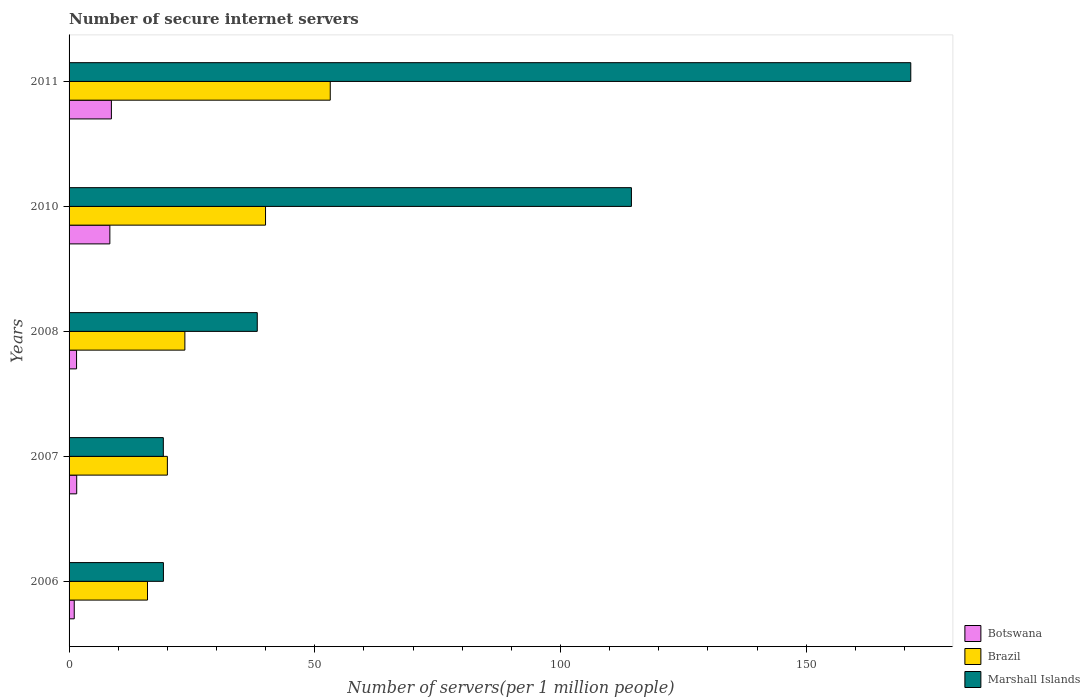How many different coloured bars are there?
Your response must be concise. 3. Are the number of bars on each tick of the Y-axis equal?
Offer a terse response. Yes. How many bars are there on the 2nd tick from the top?
Provide a succinct answer. 3. What is the label of the 1st group of bars from the top?
Your answer should be very brief. 2011. What is the number of secure internet servers in Brazil in 2007?
Make the answer very short. 20.01. Across all years, what is the maximum number of secure internet servers in Botswana?
Ensure brevity in your answer.  8.61. Across all years, what is the minimum number of secure internet servers in Botswana?
Offer a terse response. 1.06. In which year was the number of secure internet servers in Botswana minimum?
Your response must be concise. 2006. What is the total number of secure internet servers in Brazil in the graph?
Provide a succinct answer. 152.67. What is the difference between the number of secure internet servers in Brazil in 2008 and that in 2011?
Your response must be concise. -29.59. What is the difference between the number of secure internet servers in Botswana in 2011 and the number of secure internet servers in Brazil in 2008?
Your answer should be very brief. -14.95. What is the average number of secure internet servers in Marshall Islands per year?
Make the answer very short. 72.48. In the year 2010, what is the difference between the number of secure internet servers in Brazil and number of secure internet servers in Marshall Islands?
Offer a terse response. -74.46. In how many years, is the number of secure internet servers in Botswana greater than 80 ?
Your response must be concise. 0. What is the ratio of the number of secure internet servers in Marshall Islands in 2008 to that in 2010?
Ensure brevity in your answer.  0.33. Is the number of secure internet servers in Marshall Islands in 2010 less than that in 2011?
Offer a terse response. Yes. Is the difference between the number of secure internet servers in Brazil in 2010 and 2011 greater than the difference between the number of secure internet servers in Marshall Islands in 2010 and 2011?
Your answer should be compact. Yes. What is the difference between the highest and the second highest number of secure internet servers in Marshall Islands?
Provide a short and direct response. 56.85. What is the difference between the highest and the lowest number of secure internet servers in Brazil?
Your answer should be compact. 37.19. Is the sum of the number of secure internet servers in Marshall Islands in 2007 and 2011 greater than the maximum number of secure internet servers in Brazil across all years?
Give a very brief answer. Yes. What does the 1st bar from the top in 2011 represents?
Your response must be concise. Marshall Islands. What does the 2nd bar from the bottom in 2010 represents?
Make the answer very short. Brazil. How many years are there in the graph?
Give a very brief answer. 5. What is the difference between two consecutive major ticks on the X-axis?
Provide a short and direct response. 50. Are the values on the major ticks of X-axis written in scientific E-notation?
Ensure brevity in your answer.  No. Does the graph contain any zero values?
Ensure brevity in your answer.  No. Does the graph contain grids?
Ensure brevity in your answer.  No. How many legend labels are there?
Give a very brief answer. 3. How are the legend labels stacked?
Provide a succinct answer. Vertical. What is the title of the graph?
Your response must be concise. Number of secure internet servers. What is the label or title of the X-axis?
Make the answer very short. Number of servers(per 1 million people). What is the Number of servers(per 1 million people) of Botswana in 2006?
Keep it short and to the point. 1.06. What is the Number of servers(per 1 million people) in Brazil in 2006?
Provide a succinct answer. 15.96. What is the Number of servers(per 1 million people) of Marshall Islands in 2006?
Offer a very short reply. 19.2. What is the Number of servers(per 1 million people) of Botswana in 2007?
Keep it short and to the point. 1.55. What is the Number of servers(per 1 million people) in Brazil in 2007?
Your answer should be very brief. 20.01. What is the Number of servers(per 1 million people) of Marshall Islands in 2007?
Keep it short and to the point. 19.18. What is the Number of servers(per 1 million people) of Botswana in 2008?
Your answer should be very brief. 1.52. What is the Number of servers(per 1 million people) in Brazil in 2008?
Provide a short and direct response. 23.57. What is the Number of servers(per 1 million people) in Marshall Islands in 2008?
Make the answer very short. 38.3. What is the Number of servers(per 1 million people) of Botswana in 2010?
Keep it short and to the point. 8.3. What is the Number of servers(per 1 million people) of Brazil in 2010?
Your response must be concise. 39.98. What is the Number of servers(per 1 million people) of Marshall Islands in 2010?
Your answer should be compact. 114.44. What is the Number of servers(per 1 million people) of Botswana in 2011?
Your answer should be compact. 8.61. What is the Number of servers(per 1 million people) in Brazil in 2011?
Your response must be concise. 53.15. What is the Number of servers(per 1 million people) in Marshall Islands in 2011?
Give a very brief answer. 171.29. Across all years, what is the maximum Number of servers(per 1 million people) of Botswana?
Give a very brief answer. 8.61. Across all years, what is the maximum Number of servers(per 1 million people) in Brazil?
Your answer should be compact. 53.15. Across all years, what is the maximum Number of servers(per 1 million people) of Marshall Islands?
Your response must be concise. 171.29. Across all years, what is the minimum Number of servers(per 1 million people) of Botswana?
Give a very brief answer. 1.06. Across all years, what is the minimum Number of servers(per 1 million people) in Brazil?
Give a very brief answer. 15.96. Across all years, what is the minimum Number of servers(per 1 million people) in Marshall Islands?
Offer a terse response. 19.18. What is the total Number of servers(per 1 million people) in Botswana in the graph?
Provide a succinct answer. 21.05. What is the total Number of servers(per 1 million people) in Brazil in the graph?
Your answer should be compact. 152.67. What is the total Number of servers(per 1 million people) of Marshall Islands in the graph?
Provide a short and direct response. 362.42. What is the difference between the Number of servers(per 1 million people) of Botswana in 2006 and that in 2007?
Your response must be concise. -0.5. What is the difference between the Number of servers(per 1 million people) of Brazil in 2006 and that in 2007?
Provide a succinct answer. -4.04. What is the difference between the Number of servers(per 1 million people) of Marshall Islands in 2006 and that in 2007?
Your answer should be very brief. 0.02. What is the difference between the Number of servers(per 1 million people) in Botswana in 2006 and that in 2008?
Make the answer very short. -0.47. What is the difference between the Number of servers(per 1 million people) of Brazil in 2006 and that in 2008?
Your answer should be compact. -7.6. What is the difference between the Number of servers(per 1 million people) in Marshall Islands in 2006 and that in 2008?
Offer a very short reply. -19.1. What is the difference between the Number of servers(per 1 million people) in Botswana in 2006 and that in 2010?
Your answer should be very brief. -7.25. What is the difference between the Number of servers(per 1 million people) of Brazil in 2006 and that in 2010?
Your answer should be very brief. -24.02. What is the difference between the Number of servers(per 1 million people) of Marshall Islands in 2006 and that in 2010?
Offer a very short reply. -95.24. What is the difference between the Number of servers(per 1 million people) in Botswana in 2006 and that in 2011?
Make the answer very short. -7.56. What is the difference between the Number of servers(per 1 million people) in Brazil in 2006 and that in 2011?
Keep it short and to the point. -37.19. What is the difference between the Number of servers(per 1 million people) of Marshall Islands in 2006 and that in 2011?
Offer a terse response. -152.09. What is the difference between the Number of servers(per 1 million people) in Botswana in 2007 and that in 2008?
Offer a very short reply. 0.03. What is the difference between the Number of servers(per 1 million people) of Brazil in 2007 and that in 2008?
Give a very brief answer. -3.56. What is the difference between the Number of servers(per 1 million people) of Marshall Islands in 2007 and that in 2008?
Offer a very short reply. -19.12. What is the difference between the Number of servers(per 1 million people) of Botswana in 2007 and that in 2010?
Offer a very short reply. -6.75. What is the difference between the Number of servers(per 1 million people) of Brazil in 2007 and that in 2010?
Keep it short and to the point. -19.98. What is the difference between the Number of servers(per 1 million people) in Marshall Islands in 2007 and that in 2010?
Make the answer very short. -95.26. What is the difference between the Number of servers(per 1 million people) of Botswana in 2007 and that in 2011?
Your answer should be compact. -7.06. What is the difference between the Number of servers(per 1 million people) in Brazil in 2007 and that in 2011?
Your answer should be very brief. -33.15. What is the difference between the Number of servers(per 1 million people) of Marshall Islands in 2007 and that in 2011?
Provide a succinct answer. -152.11. What is the difference between the Number of servers(per 1 million people) of Botswana in 2008 and that in 2010?
Your response must be concise. -6.78. What is the difference between the Number of servers(per 1 million people) in Brazil in 2008 and that in 2010?
Keep it short and to the point. -16.42. What is the difference between the Number of servers(per 1 million people) of Marshall Islands in 2008 and that in 2010?
Keep it short and to the point. -76.14. What is the difference between the Number of servers(per 1 million people) in Botswana in 2008 and that in 2011?
Offer a terse response. -7.09. What is the difference between the Number of servers(per 1 million people) in Brazil in 2008 and that in 2011?
Offer a terse response. -29.59. What is the difference between the Number of servers(per 1 million people) of Marshall Islands in 2008 and that in 2011?
Offer a very short reply. -133. What is the difference between the Number of servers(per 1 million people) of Botswana in 2010 and that in 2011?
Give a very brief answer. -0.31. What is the difference between the Number of servers(per 1 million people) in Brazil in 2010 and that in 2011?
Make the answer very short. -13.17. What is the difference between the Number of servers(per 1 million people) in Marshall Islands in 2010 and that in 2011?
Your response must be concise. -56.85. What is the difference between the Number of servers(per 1 million people) of Botswana in 2006 and the Number of servers(per 1 million people) of Brazil in 2007?
Offer a terse response. -18.95. What is the difference between the Number of servers(per 1 million people) of Botswana in 2006 and the Number of servers(per 1 million people) of Marshall Islands in 2007?
Your answer should be very brief. -18.13. What is the difference between the Number of servers(per 1 million people) in Brazil in 2006 and the Number of servers(per 1 million people) in Marshall Islands in 2007?
Provide a succinct answer. -3.22. What is the difference between the Number of servers(per 1 million people) in Botswana in 2006 and the Number of servers(per 1 million people) in Brazil in 2008?
Offer a terse response. -22.51. What is the difference between the Number of servers(per 1 million people) in Botswana in 2006 and the Number of servers(per 1 million people) in Marshall Islands in 2008?
Give a very brief answer. -37.24. What is the difference between the Number of servers(per 1 million people) in Brazil in 2006 and the Number of servers(per 1 million people) in Marshall Islands in 2008?
Give a very brief answer. -22.34. What is the difference between the Number of servers(per 1 million people) in Botswana in 2006 and the Number of servers(per 1 million people) in Brazil in 2010?
Provide a short and direct response. -38.93. What is the difference between the Number of servers(per 1 million people) of Botswana in 2006 and the Number of servers(per 1 million people) of Marshall Islands in 2010?
Offer a very short reply. -113.39. What is the difference between the Number of servers(per 1 million people) in Brazil in 2006 and the Number of servers(per 1 million people) in Marshall Islands in 2010?
Make the answer very short. -98.48. What is the difference between the Number of servers(per 1 million people) of Botswana in 2006 and the Number of servers(per 1 million people) of Brazil in 2011?
Your answer should be very brief. -52.1. What is the difference between the Number of servers(per 1 million people) of Botswana in 2006 and the Number of servers(per 1 million people) of Marshall Islands in 2011?
Give a very brief answer. -170.24. What is the difference between the Number of servers(per 1 million people) of Brazil in 2006 and the Number of servers(per 1 million people) of Marshall Islands in 2011?
Ensure brevity in your answer.  -155.33. What is the difference between the Number of servers(per 1 million people) of Botswana in 2007 and the Number of servers(per 1 million people) of Brazil in 2008?
Provide a short and direct response. -22.01. What is the difference between the Number of servers(per 1 million people) of Botswana in 2007 and the Number of servers(per 1 million people) of Marshall Islands in 2008?
Ensure brevity in your answer.  -36.74. What is the difference between the Number of servers(per 1 million people) of Brazil in 2007 and the Number of servers(per 1 million people) of Marshall Islands in 2008?
Keep it short and to the point. -18.29. What is the difference between the Number of servers(per 1 million people) of Botswana in 2007 and the Number of servers(per 1 million people) of Brazil in 2010?
Offer a terse response. -38.43. What is the difference between the Number of servers(per 1 million people) of Botswana in 2007 and the Number of servers(per 1 million people) of Marshall Islands in 2010?
Offer a terse response. -112.89. What is the difference between the Number of servers(per 1 million people) in Brazil in 2007 and the Number of servers(per 1 million people) in Marshall Islands in 2010?
Your answer should be compact. -94.44. What is the difference between the Number of servers(per 1 million people) of Botswana in 2007 and the Number of servers(per 1 million people) of Brazil in 2011?
Your response must be concise. -51.6. What is the difference between the Number of servers(per 1 million people) of Botswana in 2007 and the Number of servers(per 1 million people) of Marshall Islands in 2011?
Offer a very short reply. -169.74. What is the difference between the Number of servers(per 1 million people) in Brazil in 2007 and the Number of servers(per 1 million people) in Marshall Islands in 2011?
Your answer should be very brief. -151.29. What is the difference between the Number of servers(per 1 million people) in Botswana in 2008 and the Number of servers(per 1 million people) in Brazil in 2010?
Your answer should be compact. -38.46. What is the difference between the Number of servers(per 1 million people) of Botswana in 2008 and the Number of servers(per 1 million people) of Marshall Islands in 2010?
Your response must be concise. -112.92. What is the difference between the Number of servers(per 1 million people) of Brazil in 2008 and the Number of servers(per 1 million people) of Marshall Islands in 2010?
Ensure brevity in your answer.  -90.88. What is the difference between the Number of servers(per 1 million people) in Botswana in 2008 and the Number of servers(per 1 million people) in Brazil in 2011?
Your answer should be compact. -51.63. What is the difference between the Number of servers(per 1 million people) in Botswana in 2008 and the Number of servers(per 1 million people) in Marshall Islands in 2011?
Your response must be concise. -169.77. What is the difference between the Number of servers(per 1 million people) of Brazil in 2008 and the Number of servers(per 1 million people) of Marshall Islands in 2011?
Ensure brevity in your answer.  -147.73. What is the difference between the Number of servers(per 1 million people) in Botswana in 2010 and the Number of servers(per 1 million people) in Brazil in 2011?
Offer a terse response. -44.85. What is the difference between the Number of servers(per 1 million people) in Botswana in 2010 and the Number of servers(per 1 million people) in Marshall Islands in 2011?
Offer a terse response. -162.99. What is the difference between the Number of servers(per 1 million people) in Brazil in 2010 and the Number of servers(per 1 million people) in Marshall Islands in 2011?
Keep it short and to the point. -131.31. What is the average Number of servers(per 1 million people) in Botswana per year?
Your answer should be very brief. 4.21. What is the average Number of servers(per 1 million people) in Brazil per year?
Ensure brevity in your answer.  30.53. What is the average Number of servers(per 1 million people) of Marshall Islands per year?
Offer a very short reply. 72.48. In the year 2006, what is the difference between the Number of servers(per 1 million people) in Botswana and Number of servers(per 1 million people) in Brazil?
Offer a very short reply. -14.91. In the year 2006, what is the difference between the Number of servers(per 1 million people) in Botswana and Number of servers(per 1 million people) in Marshall Islands?
Keep it short and to the point. -18.15. In the year 2006, what is the difference between the Number of servers(per 1 million people) in Brazil and Number of servers(per 1 million people) in Marshall Islands?
Make the answer very short. -3.24. In the year 2007, what is the difference between the Number of servers(per 1 million people) in Botswana and Number of servers(per 1 million people) in Brazil?
Provide a short and direct response. -18.45. In the year 2007, what is the difference between the Number of servers(per 1 million people) of Botswana and Number of servers(per 1 million people) of Marshall Islands?
Offer a terse response. -17.63. In the year 2007, what is the difference between the Number of servers(per 1 million people) of Brazil and Number of servers(per 1 million people) of Marshall Islands?
Offer a very short reply. 0.83. In the year 2008, what is the difference between the Number of servers(per 1 million people) in Botswana and Number of servers(per 1 million people) in Brazil?
Give a very brief answer. -22.04. In the year 2008, what is the difference between the Number of servers(per 1 million people) in Botswana and Number of servers(per 1 million people) in Marshall Islands?
Provide a succinct answer. -36.77. In the year 2008, what is the difference between the Number of servers(per 1 million people) in Brazil and Number of servers(per 1 million people) in Marshall Islands?
Your response must be concise. -14.73. In the year 2010, what is the difference between the Number of servers(per 1 million people) of Botswana and Number of servers(per 1 million people) of Brazil?
Offer a terse response. -31.68. In the year 2010, what is the difference between the Number of servers(per 1 million people) in Botswana and Number of servers(per 1 million people) in Marshall Islands?
Your answer should be compact. -106.14. In the year 2010, what is the difference between the Number of servers(per 1 million people) of Brazil and Number of servers(per 1 million people) of Marshall Islands?
Your response must be concise. -74.46. In the year 2011, what is the difference between the Number of servers(per 1 million people) in Botswana and Number of servers(per 1 million people) in Brazil?
Your answer should be compact. -44.54. In the year 2011, what is the difference between the Number of servers(per 1 million people) in Botswana and Number of servers(per 1 million people) in Marshall Islands?
Give a very brief answer. -162.68. In the year 2011, what is the difference between the Number of servers(per 1 million people) in Brazil and Number of servers(per 1 million people) in Marshall Islands?
Provide a succinct answer. -118.14. What is the ratio of the Number of servers(per 1 million people) of Botswana in 2006 to that in 2007?
Offer a very short reply. 0.68. What is the ratio of the Number of servers(per 1 million people) in Brazil in 2006 to that in 2007?
Give a very brief answer. 0.8. What is the ratio of the Number of servers(per 1 million people) in Botswana in 2006 to that in 2008?
Ensure brevity in your answer.  0.69. What is the ratio of the Number of servers(per 1 million people) in Brazil in 2006 to that in 2008?
Your answer should be very brief. 0.68. What is the ratio of the Number of servers(per 1 million people) of Marshall Islands in 2006 to that in 2008?
Provide a short and direct response. 0.5. What is the ratio of the Number of servers(per 1 million people) of Botswana in 2006 to that in 2010?
Ensure brevity in your answer.  0.13. What is the ratio of the Number of servers(per 1 million people) of Brazil in 2006 to that in 2010?
Offer a terse response. 0.4. What is the ratio of the Number of servers(per 1 million people) of Marshall Islands in 2006 to that in 2010?
Provide a short and direct response. 0.17. What is the ratio of the Number of servers(per 1 million people) in Botswana in 2006 to that in 2011?
Ensure brevity in your answer.  0.12. What is the ratio of the Number of servers(per 1 million people) in Brazil in 2006 to that in 2011?
Offer a terse response. 0.3. What is the ratio of the Number of servers(per 1 million people) of Marshall Islands in 2006 to that in 2011?
Provide a succinct answer. 0.11. What is the ratio of the Number of servers(per 1 million people) in Botswana in 2007 to that in 2008?
Give a very brief answer. 1.02. What is the ratio of the Number of servers(per 1 million people) of Brazil in 2007 to that in 2008?
Your answer should be compact. 0.85. What is the ratio of the Number of servers(per 1 million people) of Marshall Islands in 2007 to that in 2008?
Your answer should be very brief. 0.5. What is the ratio of the Number of servers(per 1 million people) of Botswana in 2007 to that in 2010?
Your response must be concise. 0.19. What is the ratio of the Number of servers(per 1 million people) of Brazil in 2007 to that in 2010?
Offer a very short reply. 0.5. What is the ratio of the Number of servers(per 1 million people) of Marshall Islands in 2007 to that in 2010?
Your answer should be compact. 0.17. What is the ratio of the Number of servers(per 1 million people) of Botswana in 2007 to that in 2011?
Give a very brief answer. 0.18. What is the ratio of the Number of servers(per 1 million people) in Brazil in 2007 to that in 2011?
Provide a succinct answer. 0.38. What is the ratio of the Number of servers(per 1 million people) of Marshall Islands in 2007 to that in 2011?
Your answer should be very brief. 0.11. What is the ratio of the Number of servers(per 1 million people) of Botswana in 2008 to that in 2010?
Provide a short and direct response. 0.18. What is the ratio of the Number of servers(per 1 million people) in Brazil in 2008 to that in 2010?
Ensure brevity in your answer.  0.59. What is the ratio of the Number of servers(per 1 million people) of Marshall Islands in 2008 to that in 2010?
Your answer should be very brief. 0.33. What is the ratio of the Number of servers(per 1 million people) in Botswana in 2008 to that in 2011?
Give a very brief answer. 0.18. What is the ratio of the Number of servers(per 1 million people) in Brazil in 2008 to that in 2011?
Provide a short and direct response. 0.44. What is the ratio of the Number of servers(per 1 million people) in Marshall Islands in 2008 to that in 2011?
Offer a very short reply. 0.22. What is the ratio of the Number of servers(per 1 million people) of Botswana in 2010 to that in 2011?
Your answer should be very brief. 0.96. What is the ratio of the Number of servers(per 1 million people) in Brazil in 2010 to that in 2011?
Offer a very short reply. 0.75. What is the ratio of the Number of servers(per 1 million people) in Marshall Islands in 2010 to that in 2011?
Your answer should be very brief. 0.67. What is the difference between the highest and the second highest Number of servers(per 1 million people) of Botswana?
Your answer should be very brief. 0.31. What is the difference between the highest and the second highest Number of servers(per 1 million people) in Brazil?
Provide a succinct answer. 13.17. What is the difference between the highest and the second highest Number of servers(per 1 million people) of Marshall Islands?
Offer a very short reply. 56.85. What is the difference between the highest and the lowest Number of servers(per 1 million people) of Botswana?
Your answer should be very brief. 7.56. What is the difference between the highest and the lowest Number of servers(per 1 million people) of Brazil?
Ensure brevity in your answer.  37.19. What is the difference between the highest and the lowest Number of servers(per 1 million people) in Marshall Islands?
Your answer should be very brief. 152.11. 